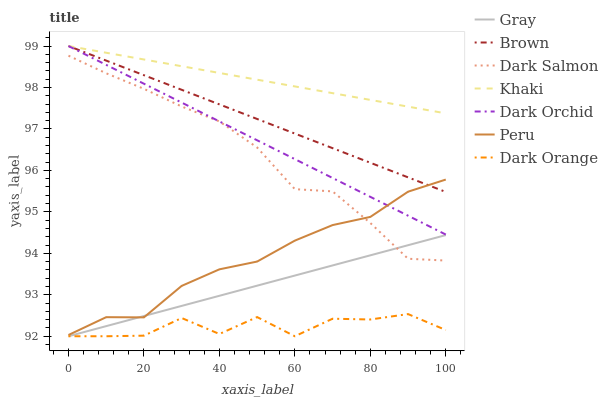Does Dark Orange have the minimum area under the curve?
Answer yes or no. Yes. Does Khaki have the maximum area under the curve?
Answer yes or no. Yes. Does Brown have the minimum area under the curve?
Answer yes or no. No. Does Brown have the maximum area under the curve?
Answer yes or no. No. Is Khaki the smoothest?
Answer yes or no. Yes. Is Dark Orange the roughest?
Answer yes or no. Yes. Is Brown the smoothest?
Answer yes or no. No. Is Brown the roughest?
Answer yes or no. No. Does Gray have the lowest value?
Answer yes or no. Yes. Does Brown have the lowest value?
Answer yes or no. No. Does Dark Orchid have the highest value?
Answer yes or no. Yes. Does Dark Salmon have the highest value?
Answer yes or no. No. Is Gray less than Dark Orchid?
Answer yes or no. Yes. Is Brown greater than Gray?
Answer yes or no. Yes. Does Gray intersect Dark Salmon?
Answer yes or no. Yes. Is Gray less than Dark Salmon?
Answer yes or no. No. Is Gray greater than Dark Salmon?
Answer yes or no. No. Does Gray intersect Dark Orchid?
Answer yes or no. No. 